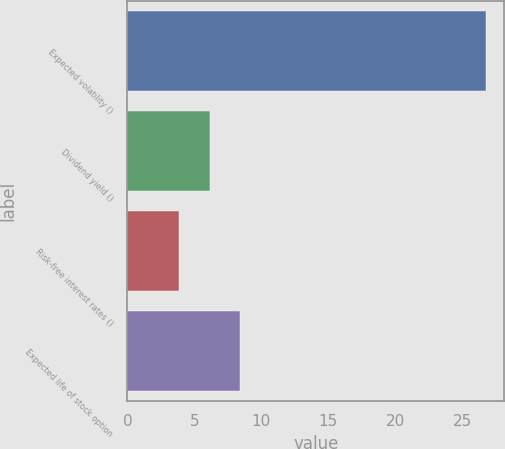Convert chart to OTSL. <chart><loc_0><loc_0><loc_500><loc_500><bar_chart><fcel>Expected volatility ()<fcel>Dividend yield ()<fcel>Risk-free interest rates ()<fcel>Expected life of stock option<nl><fcel>26.8<fcel>6.14<fcel>3.84<fcel>8.44<nl></chart> 